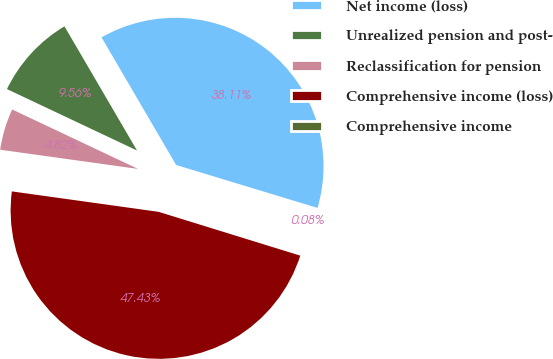Convert chart to OTSL. <chart><loc_0><loc_0><loc_500><loc_500><pie_chart><fcel>Net income (loss)<fcel>Unrealized pension and post-<fcel>Reclassification for pension<fcel>Comprehensive income (loss)<fcel>Comprehensive income<nl><fcel>38.11%<fcel>9.56%<fcel>4.82%<fcel>47.43%<fcel>0.08%<nl></chart> 